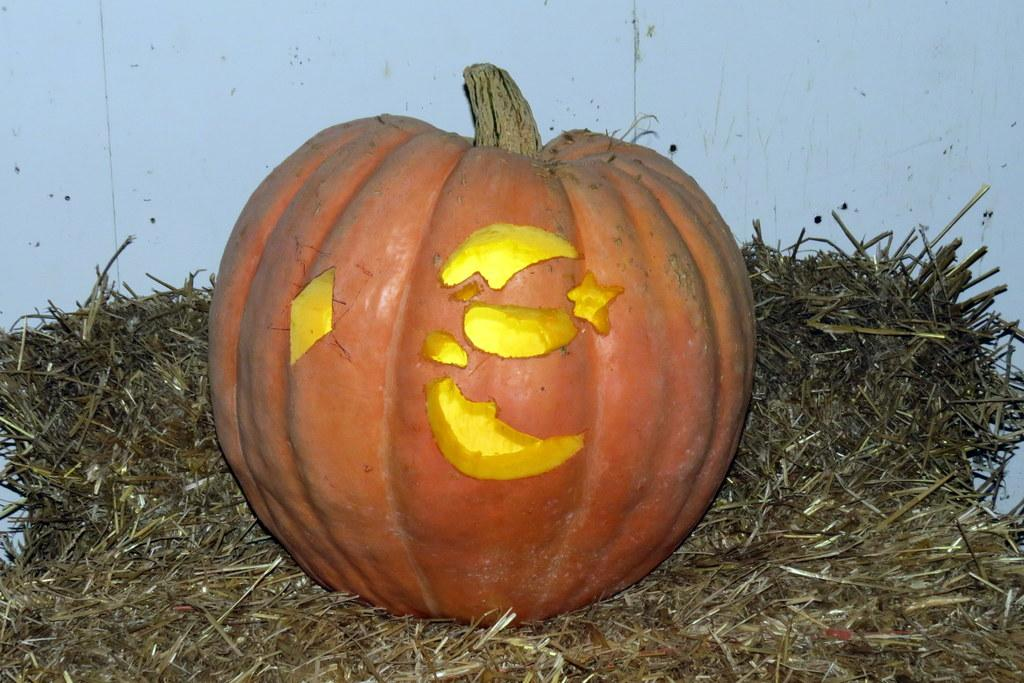What is the main object in the image? There is a pumpkin in the image. What type of vegetation is present in the image? There is grass in the image. Can you describe any other colors or objects in the image? There is a white color in the image, but its context is unclear. What type of cart is being pulled by the stranger in the image? There is no cart or stranger present in the image; it only features a pumpkin and grass. How many potatoes can be seen in the image? There are no potatoes present in the image. 